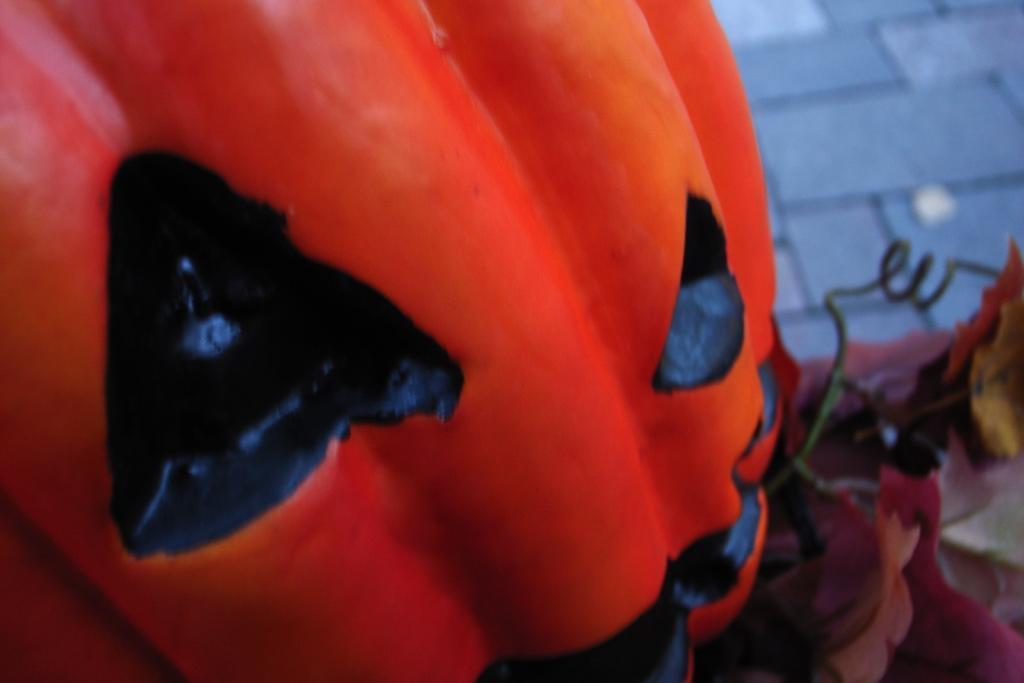Describe this image in one or two sentences. In this picture it looks like a pumpkin in the front, in the background there are some tiles, we can see a blurry background. 